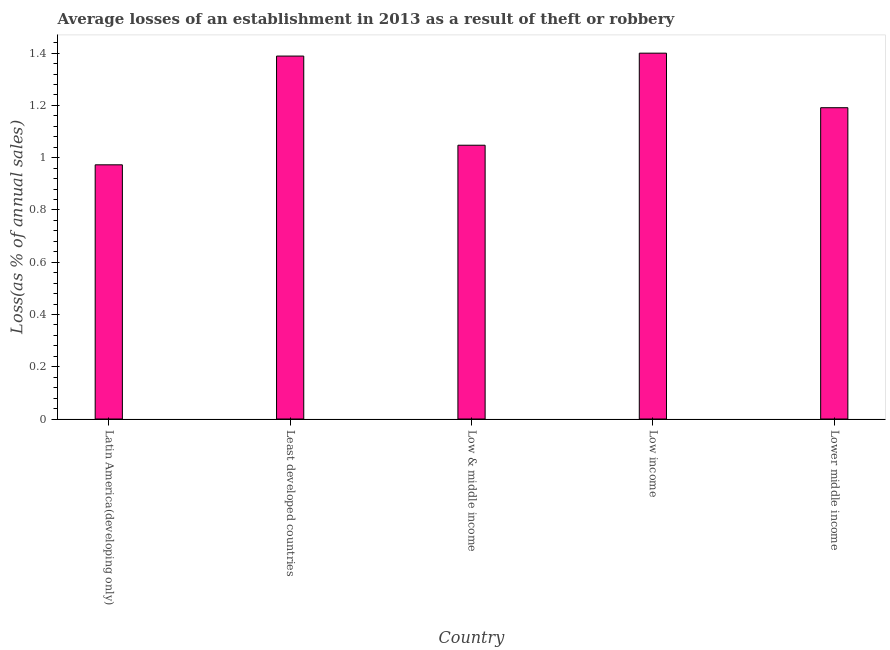What is the title of the graph?
Provide a succinct answer. Average losses of an establishment in 2013 as a result of theft or robbery. What is the label or title of the Y-axis?
Provide a short and direct response. Loss(as % of annual sales). What is the losses due to theft in Low income?
Give a very brief answer. 1.4. Across all countries, what is the minimum losses due to theft?
Provide a short and direct response. 0.97. In which country was the losses due to theft maximum?
Offer a very short reply. Low income. In which country was the losses due to theft minimum?
Your answer should be compact. Latin America(developing only). What is the sum of the losses due to theft?
Ensure brevity in your answer.  6. What is the difference between the losses due to theft in Low & middle income and Lower middle income?
Make the answer very short. -0.14. What is the average losses due to theft per country?
Ensure brevity in your answer.  1.2. What is the median losses due to theft?
Keep it short and to the point. 1.19. In how many countries, is the losses due to theft greater than 0.2 %?
Keep it short and to the point. 5. What is the ratio of the losses due to theft in Least developed countries to that in Lower middle income?
Your answer should be very brief. 1.17. Is the losses due to theft in Least developed countries less than that in Low income?
Your response must be concise. Yes. Is the difference between the losses due to theft in Latin America(developing only) and Low & middle income greater than the difference between any two countries?
Your answer should be very brief. No. What is the difference between the highest and the second highest losses due to theft?
Give a very brief answer. 0.01. What is the difference between the highest and the lowest losses due to theft?
Offer a terse response. 0.43. In how many countries, is the losses due to theft greater than the average losses due to theft taken over all countries?
Your answer should be very brief. 2. How many countries are there in the graph?
Offer a very short reply. 5. What is the Loss(as % of annual sales) of Latin America(developing only)?
Give a very brief answer. 0.97. What is the Loss(as % of annual sales) of Least developed countries?
Provide a succinct answer. 1.39. What is the Loss(as % of annual sales) of Low & middle income?
Your answer should be very brief. 1.05. What is the Loss(as % of annual sales) of Lower middle income?
Keep it short and to the point. 1.19. What is the difference between the Loss(as % of annual sales) in Latin America(developing only) and Least developed countries?
Offer a terse response. -0.42. What is the difference between the Loss(as % of annual sales) in Latin America(developing only) and Low & middle income?
Your answer should be compact. -0.07. What is the difference between the Loss(as % of annual sales) in Latin America(developing only) and Low income?
Your answer should be very brief. -0.43. What is the difference between the Loss(as % of annual sales) in Latin America(developing only) and Lower middle income?
Your answer should be very brief. -0.22. What is the difference between the Loss(as % of annual sales) in Least developed countries and Low & middle income?
Keep it short and to the point. 0.34. What is the difference between the Loss(as % of annual sales) in Least developed countries and Low income?
Provide a short and direct response. -0.01. What is the difference between the Loss(as % of annual sales) in Least developed countries and Lower middle income?
Give a very brief answer. 0.2. What is the difference between the Loss(as % of annual sales) in Low & middle income and Low income?
Provide a short and direct response. -0.35. What is the difference between the Loss(as % of annual sales) in Low & middle income and Lower middle income?
Keep it short and to the point. -0.14. What is the difference between the Loss(as % of annual sales) in Low income and Lower middle income?
Provide a short and direct response. 0.21. What is the ratio of the Loss(as % of annual sales) in Latin America(developing only) to that in Low & middle income?
Your answer should be compact. 0.93. What is the ratio of the Loss(as % of annual sales) in Latin America(developing only) to that in Low income?
Provide a short and direct response. 0.69. What is the ratio of the Loss(as % of annual sales) in Latin America(developing only) to that in Lower middle income?
Offer a terse response. 0.82. What is the ratio of the Loss(as % of annual sales) in Least developed countries to that in Low & middle income?
Your answer should be compact. 1.33. What is the ratio of the Loss(as % of annual sales) in Least developed countries to that in Lower middle income?
Give a very brief answer. 1.17. What is the ratio of the Loss(as % of annual sales) in Low & middle income to that in Low income?
Ensure brevity in your answer.  0.75. What is the ratio of the Loss(as % of annual sales) in Low & middle income to that in Lower middle income?
Your response must be concise. 0.88. What is the ratio of the Loss(as % of annual sales) in Low income to that in Lower middle income?
Provide a short and direct response. 1.18. 